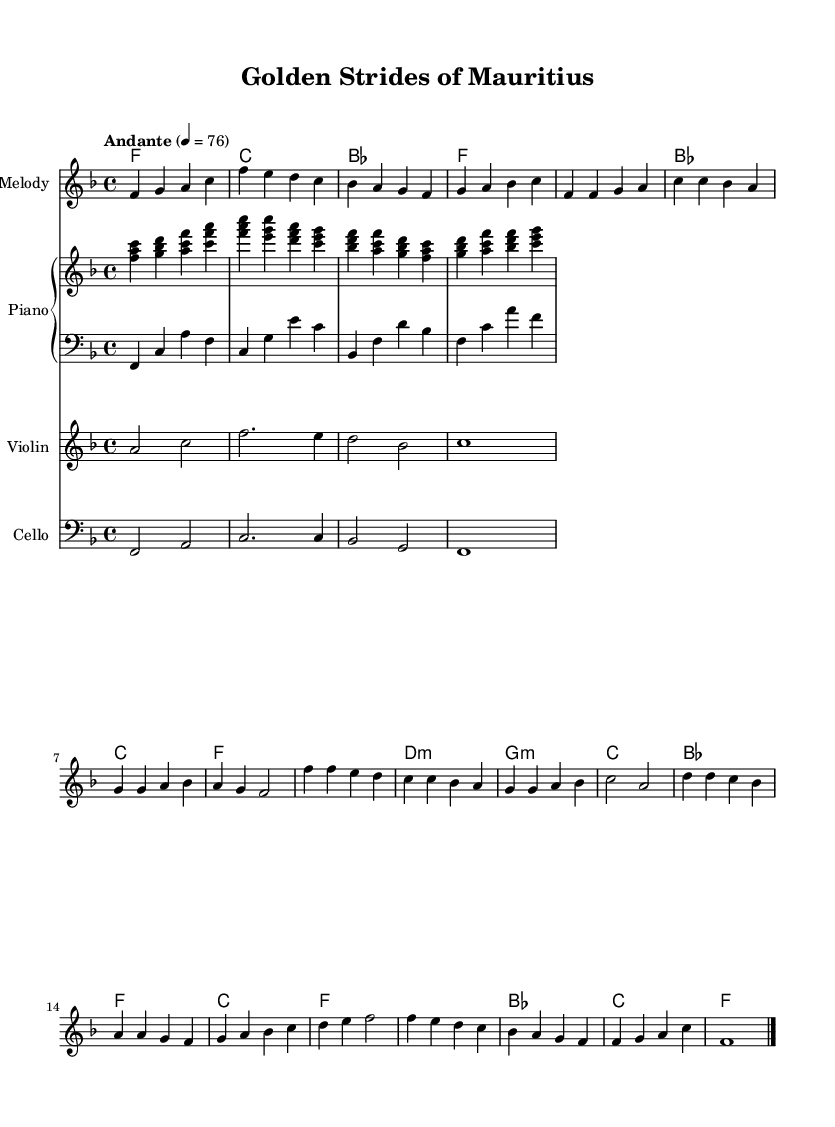What is the key signature of this music? The key signature is F major, which has one flat (B flat). This can be determined from the key signature notation appearing at the beginning of the staff.
Answer: F major What is the time signature of this piece? The time signature is 4/4, indicated at the beginning of the sheet music, which shows that there are four beats per measure and the quarter note receives one beat.
Answer: 4/4 What is the tempo marking for this piece? The tempo marking is "Andante," which indicates a moderate pace. This is shown in the tempo indication that appears at the start of the score.
Answer: Andante How many measures are in the chorus section? The chorus section consists of four measures, as counted by the number of distinct pairs of vertical lines shown in that segment of the music.
Answer: 4 Which instruments are used in this arrangement? The arrangement includes melody, piano (upper and lower), violin, and cello. This can be identified from the different staves labeled for each instrument within the score.
Answer: Melody, Piano, Violin, Cello What chord is used in the first measure? The first measure contains an F major chord, which is seen in the chord symbols above the staff corresponding to that measure.
Answer: F major How does the bridge section differ from the chorus in terms of harmony? The bridge section has a B flat major chord, while the chorus section utilizes an F major and D minor chord, indicating a shift in harmonic structure between these parts. This can be understood by comparing the chord symbols indicated throughout the respective sections.
Answer: B flat major (bridge) vs. F major & D minor (chorus) 